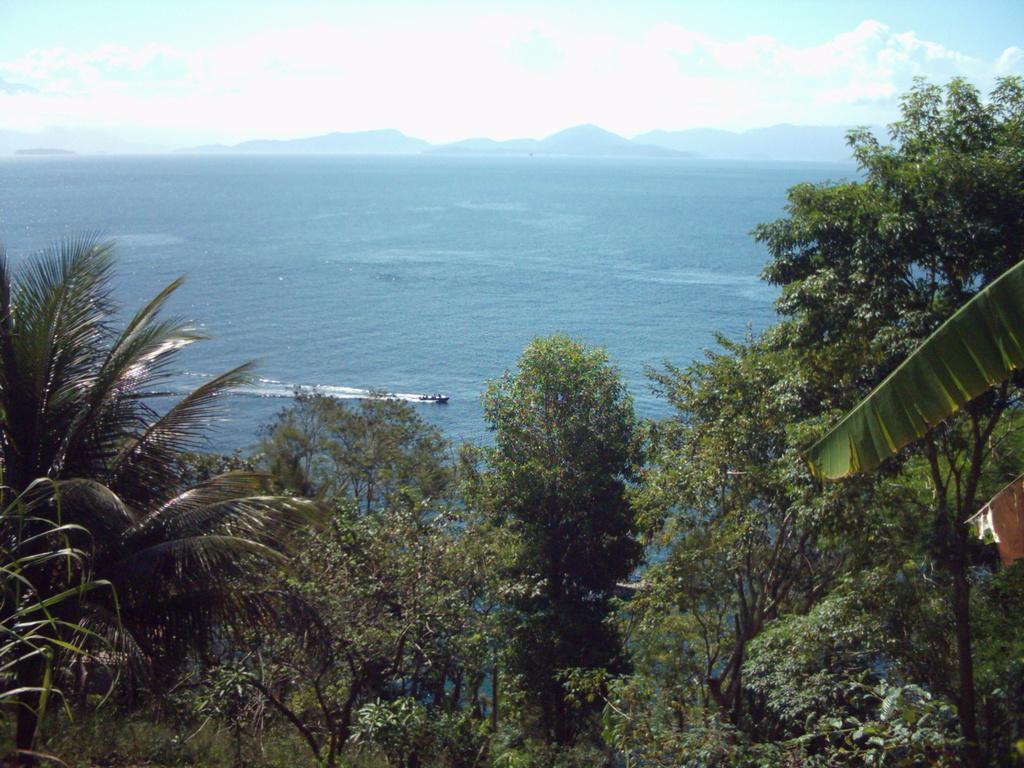Can you describe this image briefly? In this image, we can see some plants and trees. We can see the water with some object. We can also see some hills and the sky with clouds. 